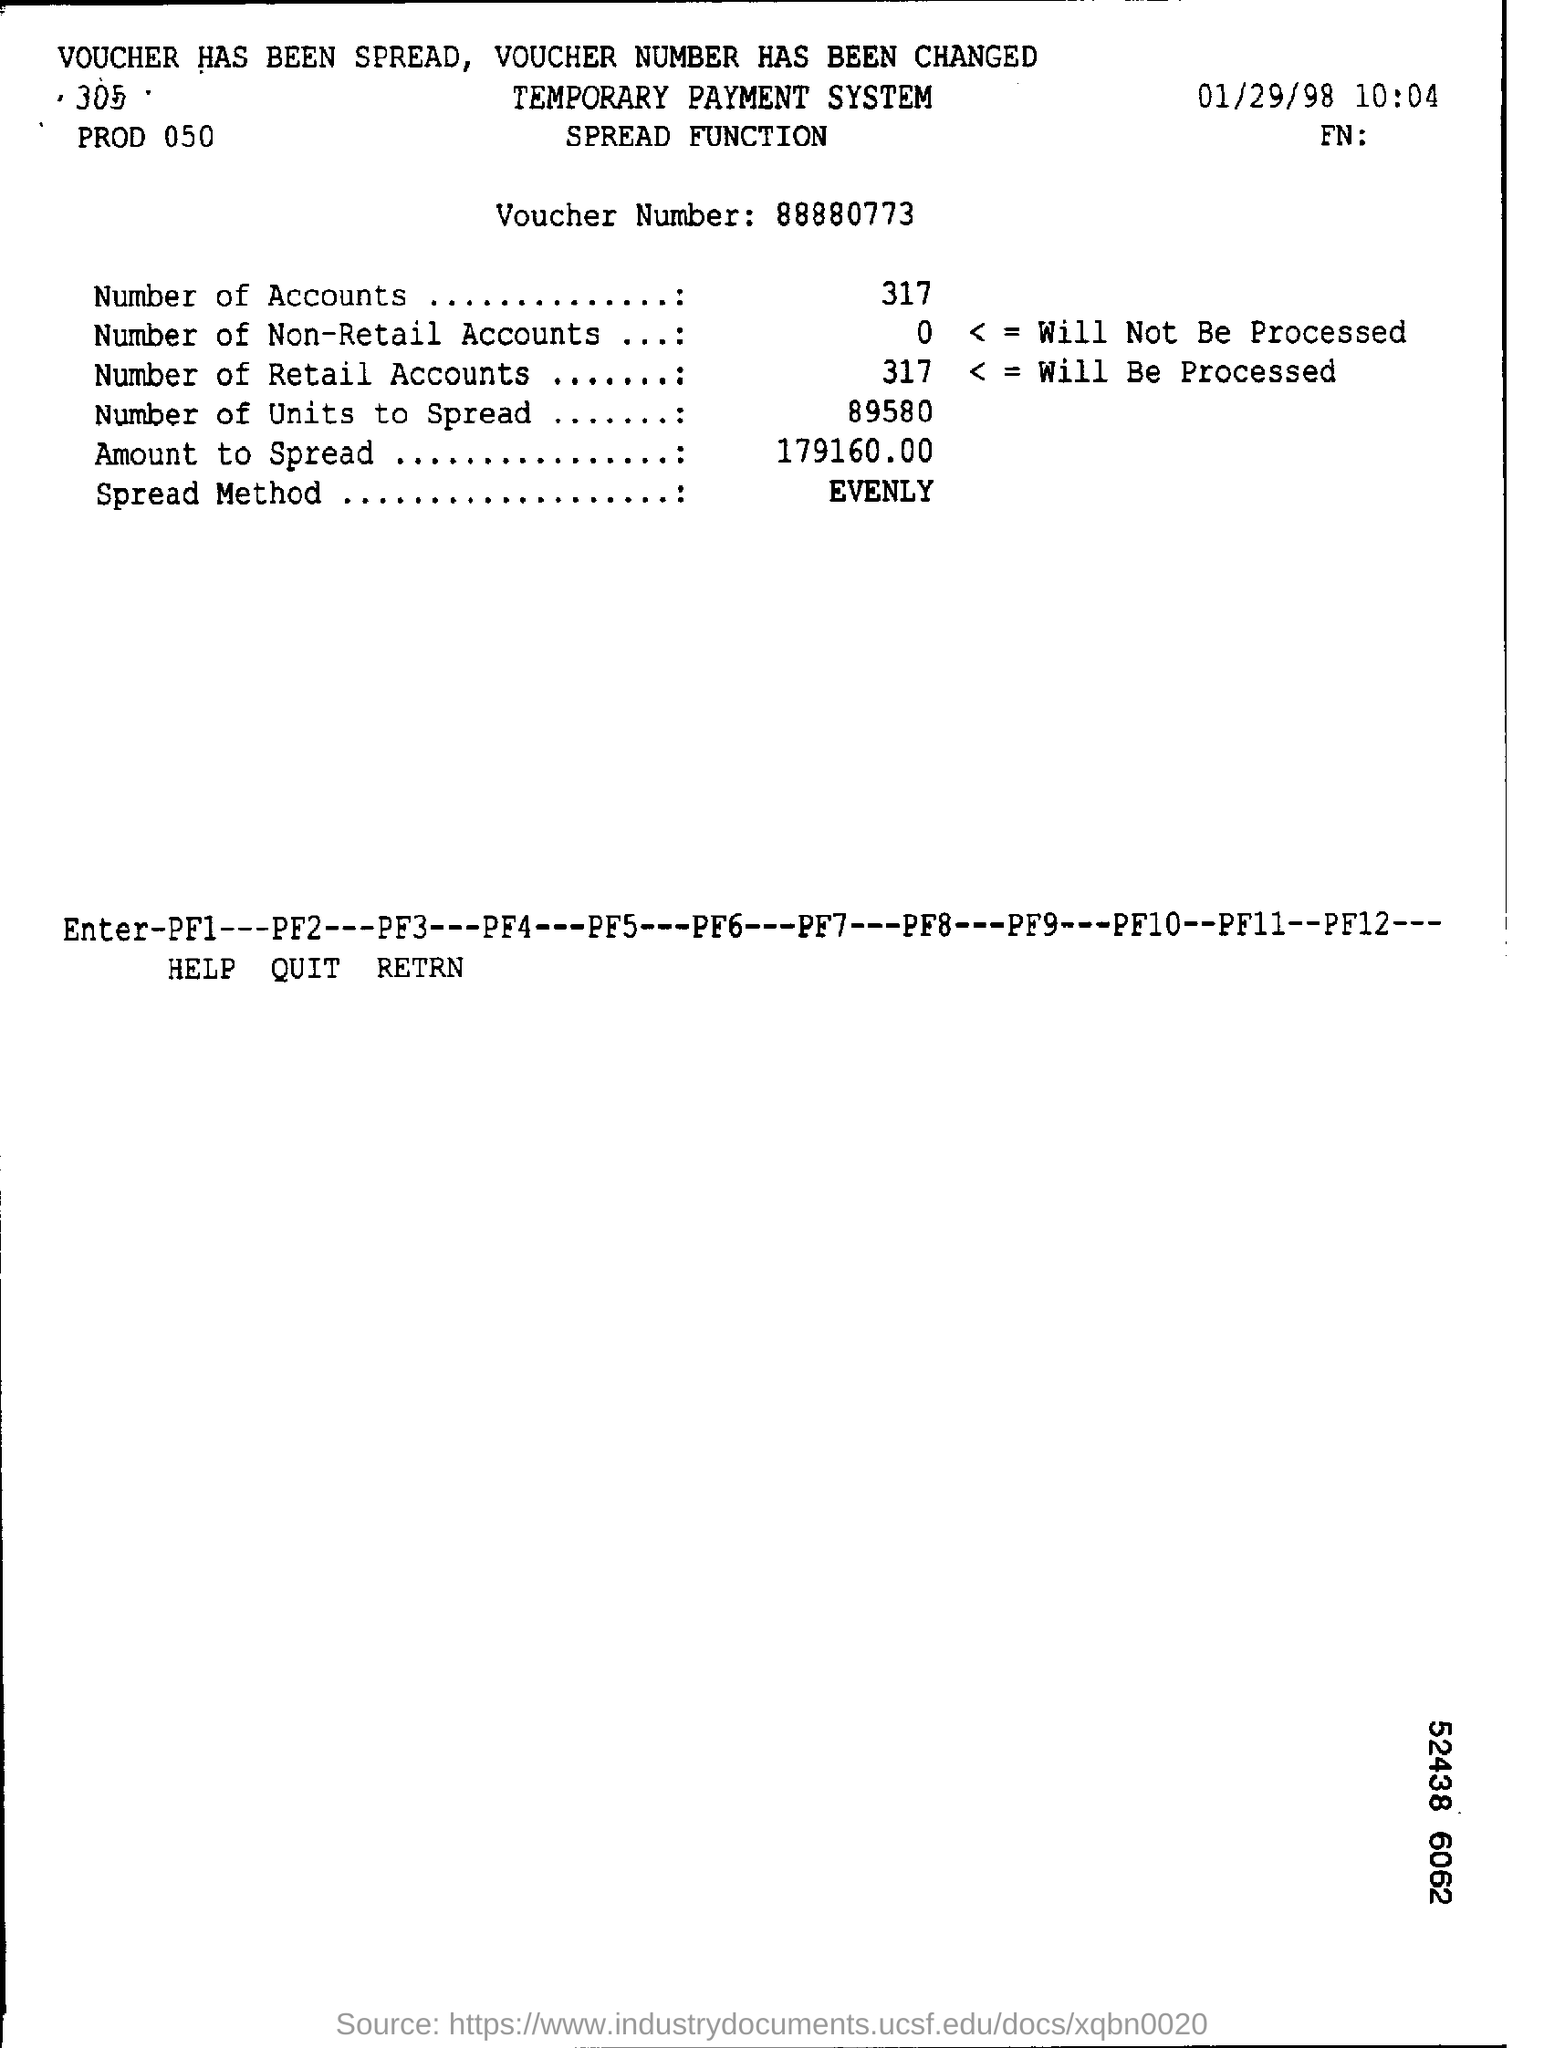What is the Voucher Number?
Make the answer very short. 88880773. How many Number of Accounts?
Provide a succinct answer. 317. What are the Number of Retail Accounts?
Provide a succinct answer. 317. What are the Number of Units to Spread?
Offer a terse response. 89580. What is the Amount to Spread?
Provide a succinct answer. 179160.00. What is the Spread Method?
Provide a succinct answer. Evenly. 